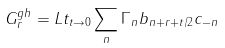Convert formula to latex. <formula><loc_0><loc_0><loc_500><loc_500>G _ { r } ^ { g h } = L t _ { t \rightarrow 0 } \sum _ { n } \Gamma _ { n } b _ { n + r + t / 2 } c _ { - n }</formula> 